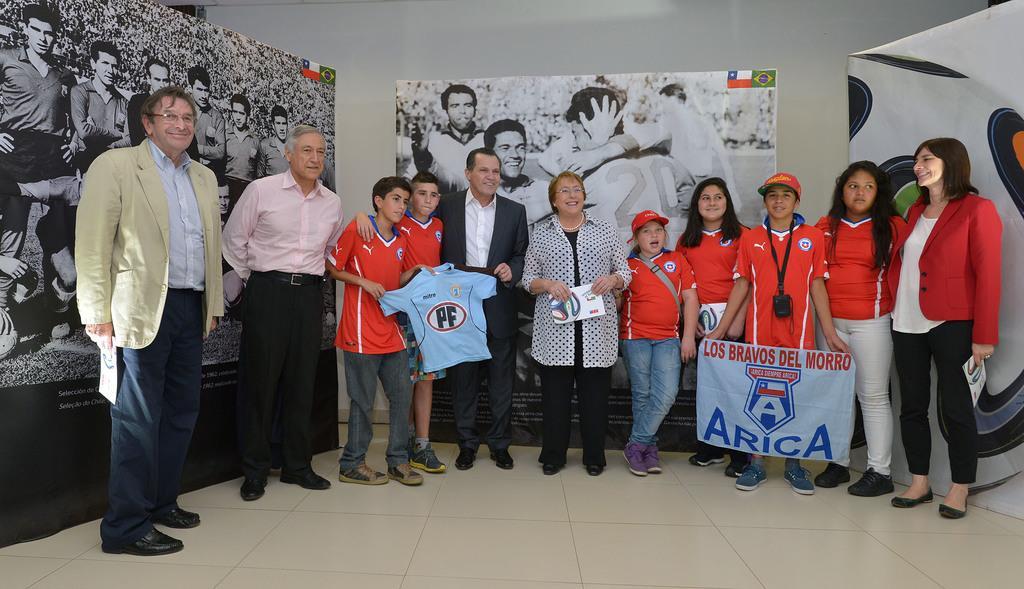Could you give a brief overview of what you see in this image? This image is taken indoors. At the bottom of the image there is a floor. In the background there is a wall and there are a few banners with a few images of men and flags on them. In the middle of the image a few men, a few women and a few kids are standing on the floor. A kid is holding a T-shirt in hand and a girl is holding a banner with a text on it. 